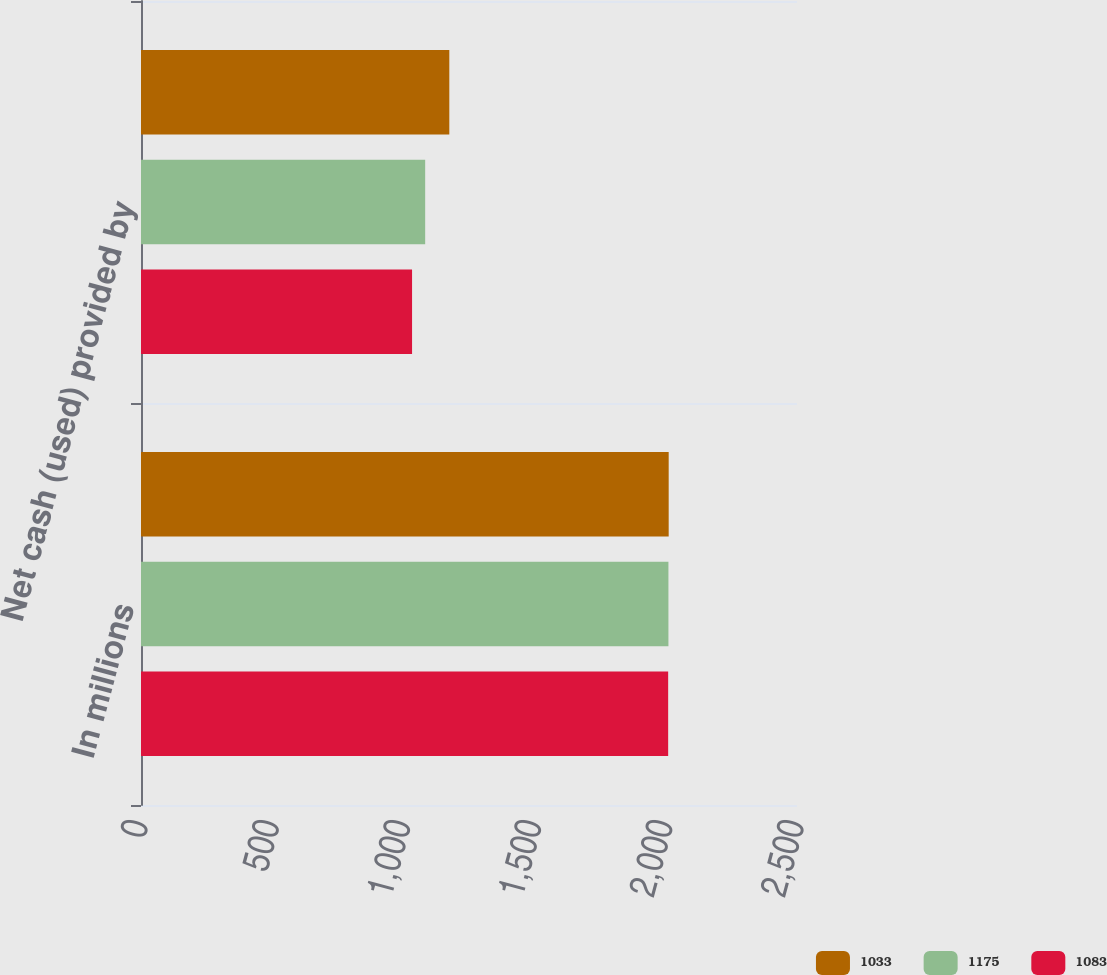Convert chart to OTSL. <chart><loc_0><loc_0><loc_500><loc_500><stacked_bar_chart><ecel><fcel>In millions<fcel>Net cash (used) provided by<nl><fcel>1033<fcel>2011<fcel>1175<nl><fcel>1175<fcel>2010<fcel>1083<nl><fcel>1083<fcel>2009<fcel>1033<nl></chart> 